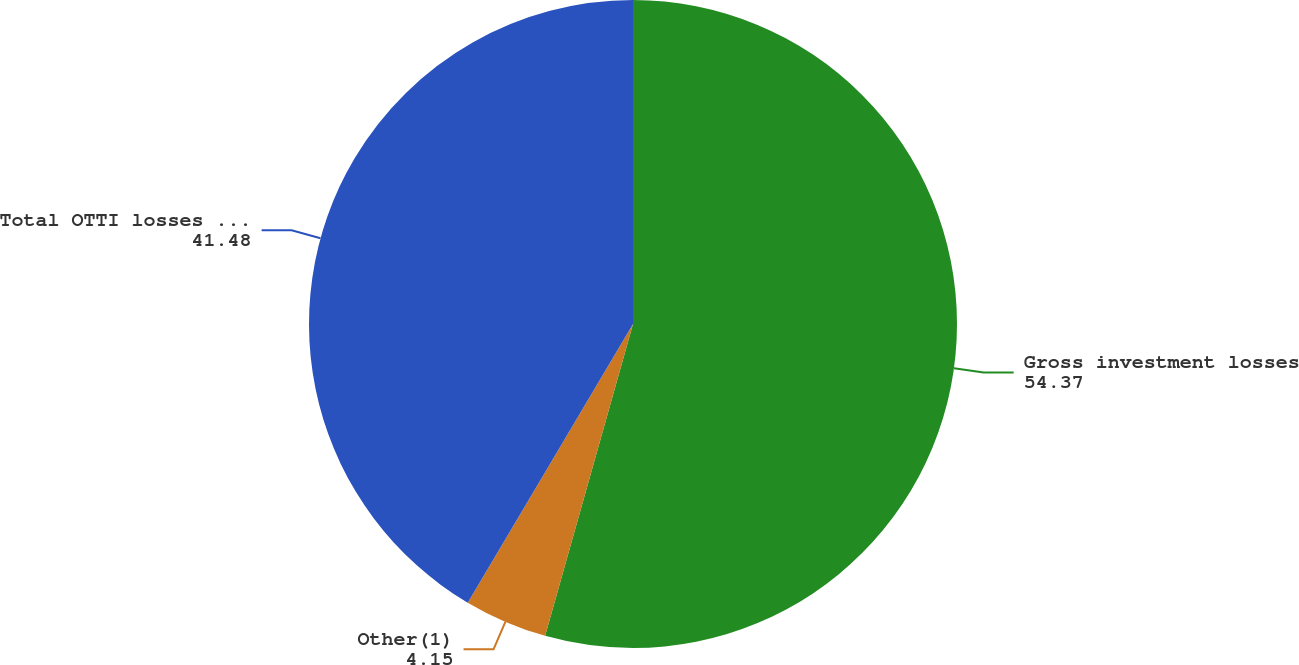Convert chart to OTSL. <chart><loc_0><loc_0><loc_500><loc_500><pie_chart><fcel>Gross investment losses<fcel>Other(1)<fcel>Total OTTI losses recognized<nl><fcel>54.37%<fcel>4.15%<fcel>41.48%<nl></chart> 